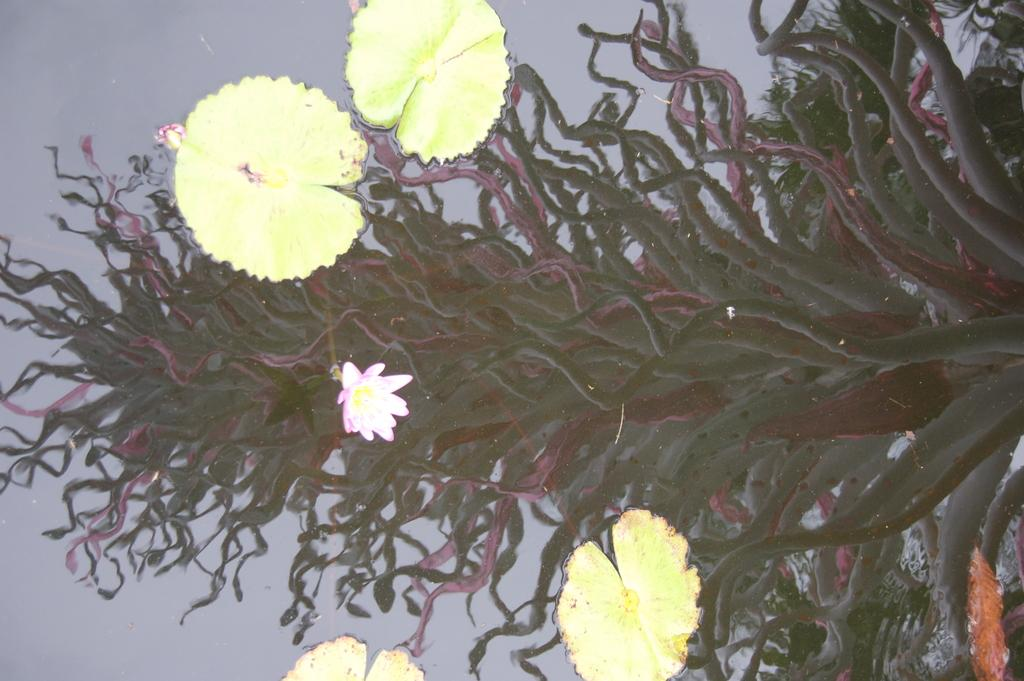What type of plant can be seen in the image? There are lotus leaves and flowers in the image. Where are the lotus leaves and flowers located? The lotus leaves and flowers are in the water. Can you describe any other visual effects in the image? There is a reflection of a plant visible in the image. How does the monkey feel about the disgusting tail in the image? There is no monkey or tail present in the image; it features lotus leaves and flowers in the water. 